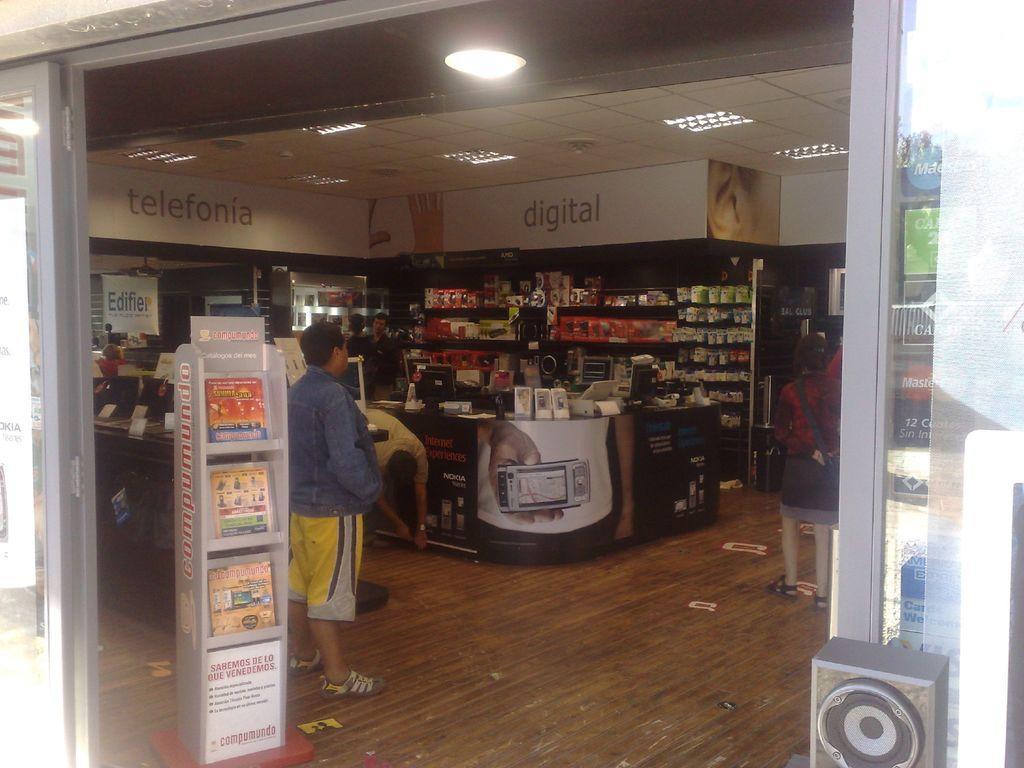In one or two sentences, can you explain what this image depicts? n this image i can see a person standing, wearing blue shirt and yellow pant, at the back ground i can see few boxes, covered, deck on a rack, there are few boxes, a desk top, a printer on a table, at the top there is a board and few lights, at the back of a person there are few magazines on a shelf, at right there is other person standing wearing red shirt and black pant. 